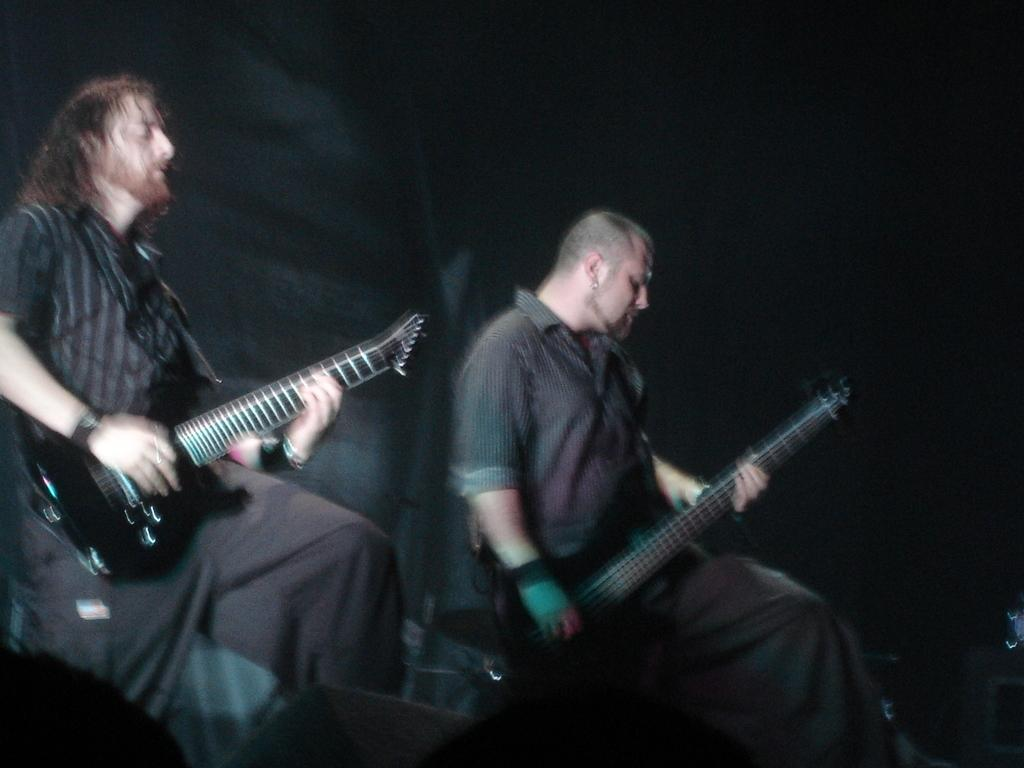How many people are in the image? There are two persons in the image. What are the people wearing? Both persons are wearing black dresses. What activity are the people engaged in? The persons are playing guitar. What type of bed can be seen in the image? There is no bed present in the image. How many songs are the people singing in the image? The image does not show the people singing, only playing guitar. 